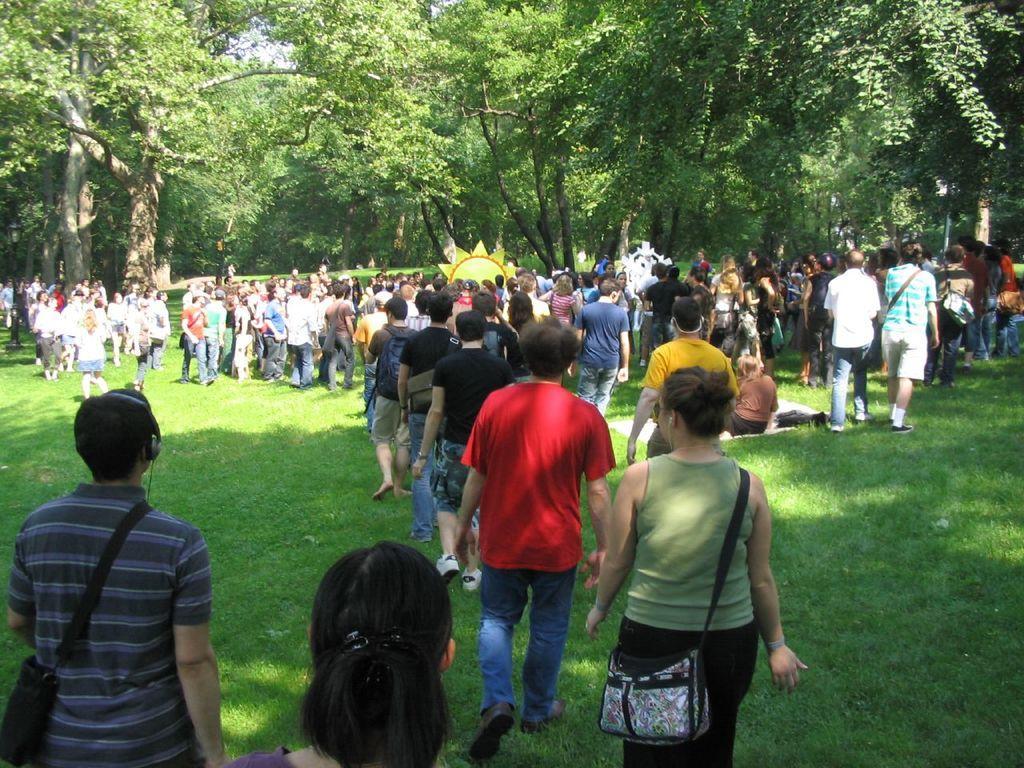How would you summarize this image in a sentence or two? In this image we can see many people. Some are wearing bags. On the ground there is grass. In the background there are trees. 